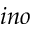Convert formula to latex. <formula><loc_0><loc_0><loc_500><loc_500>i n o</formula> 